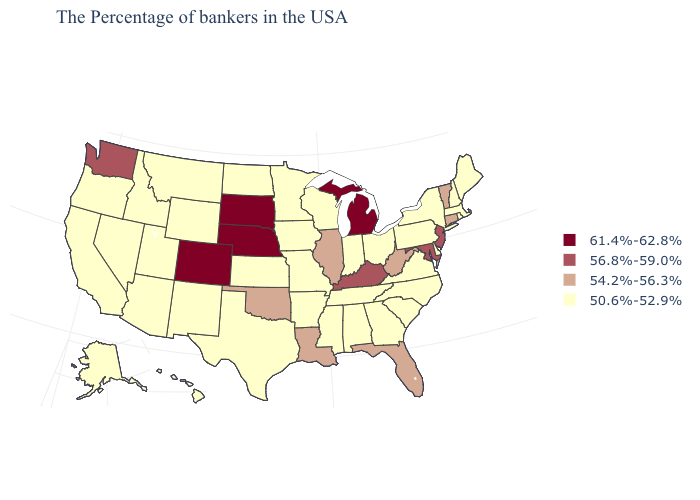What is the value of Maine?
Quick response, please. 50.6%-52.9%. How many symbols are there in the legend?
Write a very short answer. 4. What is the value of Louisiana?
Quick response, please. 54.2%-56.3%. Does Minnesota have the lowest value in the MidWest?
Give a very brief answer. Yes. Name the states that have a value in the range 54.2%-56.3%?
Concise answer only. Vermont, Connecticut, West Virginia, Florida, Illinois, Louisiana, Oklahoma. What is the highest value in the USA?
Write a very short answer. 61.4%-62.8%. Name the states that have a value in the range 54.2%-56.3%?
Answer briefly. Vermont, Connecticut, West Virginia, Florida, Illinois, Louisiana, Oklahoma. Which states have the lowest value in the South?
Keep it brief. Delaware, Virginia, North Carolina, South Carolina, Georgia, Alabama, Tennessee, Mississippi, Arkansas, Texas. Name the states that have a value in the range 50.6%-52.9%?
Answer briefly. Maine, Massachusetts, Rhode Island, New Hampshire, New York, Delaware, Pennsylvania, Virginia, North Carolina, South Carolina, Ohio, Georgia, Indiana, Alabama, Tennessee, Wisconsin, Mississippi, Missouri, Arkansas, Minnesota, Iowa, Kansas, Texas, North Dakota, Wyoming, New Mexico, Utah, Montana, Arizona, Idaho, Nevada, California, Oregon, Alaska, Hawaii. Among the states that border Montana , does Wyoming have the lowest value?
Give a very brief answer. Yes. Does Colorado have the highest value in the USA?
Be succinct. Yes. What is the highest value in the South ?
Concise answer only. 56.8%-59.0%. Does the first symbol in the legend represent the smallest category?
Give a very brief answer. No. What is the lowest value in the USA?
Write a very short answer. 50.6%-52.9%. Does the first symbol in the legend represent the smallest category?
Write a very short answer. No. 